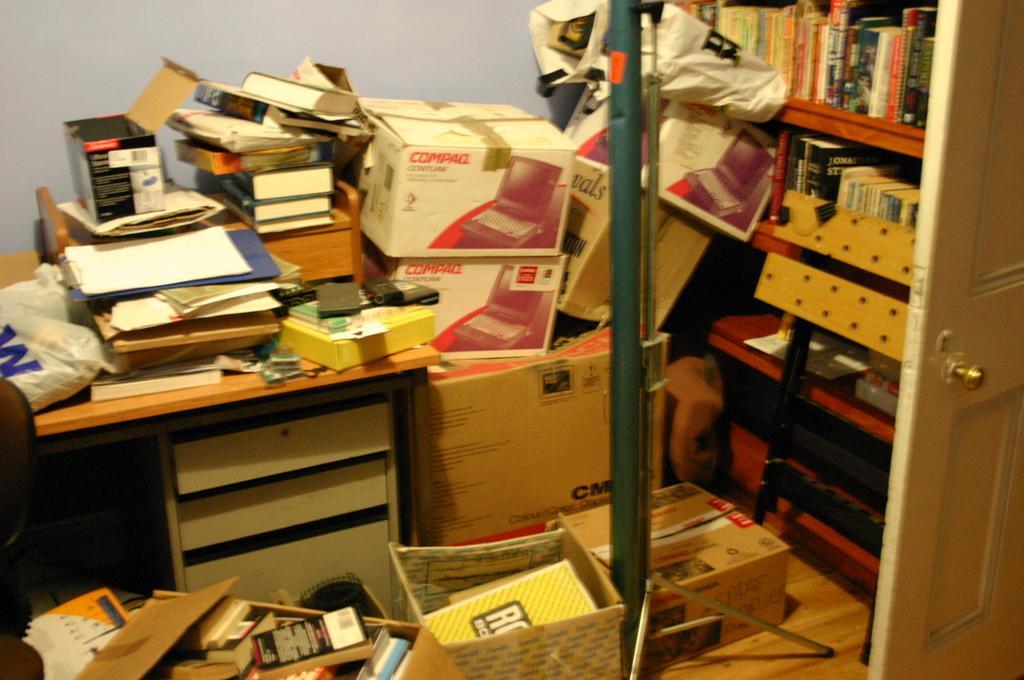In one or two sentences, can you explain what this image depicts? This picture describes about books in the book shelf and few boxes on the table. 